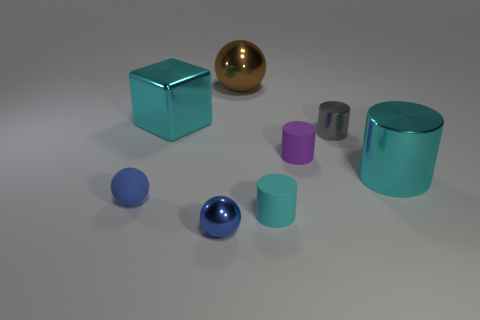Subtract 1 cylinders. How many cylinders are left? 3 Subtract all small gray cylinders. How many cylinders are left? 3 Subtract all yellow cylinders. Subtract all cyan cubes. How many cylinders are left? 4 Add 2 big gray cubes. How many objects exist? 10 Subtract all blocks. How many objects are left? 7 Subtract all tiny blue metal spheres. Subtract all small blue metal things. How many objects are left? 6 Add 7 tiny blue metallic objects. How many tiny blue metallic objects are left? 8 Add 2 small blue shiny objects. How many small blue shiny objects exist? 3 Subtract 0 yellow balls. How many objects are left? 8 